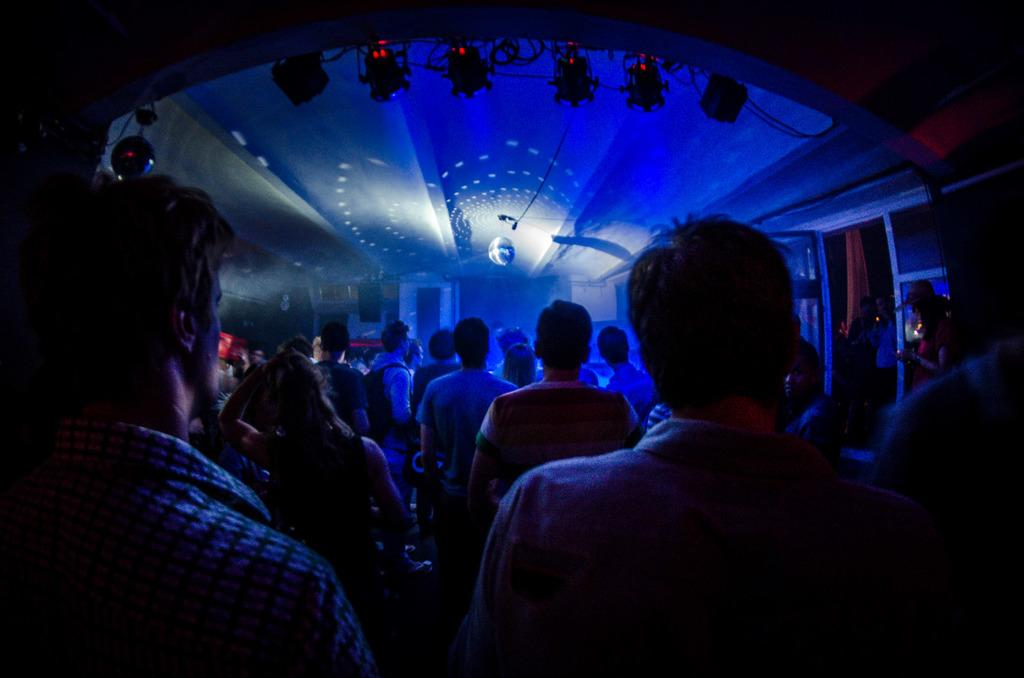What is the main subject of the image? The main subject of the image is a crowd of people. Can you describe the lighting in the image? There is colorful lighting visible at the top of the image. What type of silver tray is being used by the rabbit in the image? There is no rabbit or silver tray present in the image. 